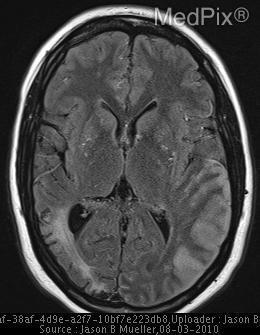Is there evidence of grey matter edema?
Give a very brief answer. Yes. Is the csf radiolucent or radioopaque?
Answer briefly. Radiolucent. What is the intensity signal of csf?
Short answer required. Hypointense. What modality is this image taken?
Quick response, please. Mri. Is this image of a saggital plane?
Write a very short answer. No. What section is this image?
Short answer required. Axial. What plane is this image taken?
Quick response, please. Axial. What organ is this image of?
Be succinct. Brain. Is there a midline shift?
Be succinct. No. Is there structural deviation from the midline?
Keep it brief. No. 